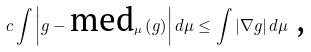Convert formula to latex. <formula><loc_0><loc_0><loc_500><loc_500>c \int \left | g - \text {med} _ { \mu } \left ( g \right ) \right | d \mu \leq \int \left | \nabla g \right | d \mu \text { ,}</formula> 